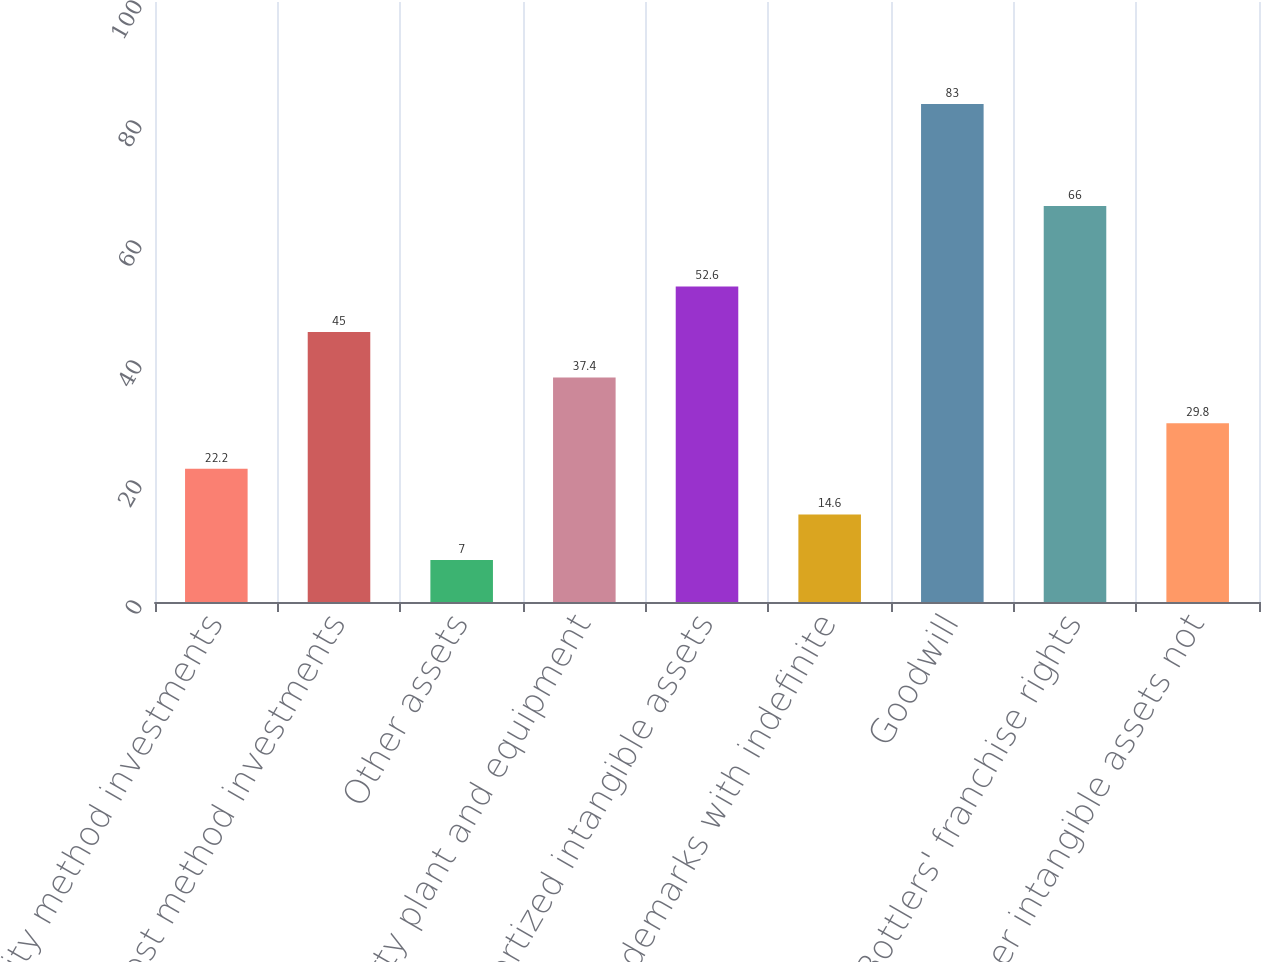Convert chart. <chart><loc_0><loc_0><loc_500><loc_500><bar_chart><fcel>Equity method investments<fcel>Cost method investments<fcel>Other assets<fcel>Property plant and equipment<fcel>Amortized intangible assets<fcel>Trademarks with indefinite<fcel>Goodwill<fcel>Bottlers' franchise rights<fcel>Other intangible assets not<nl><fcel>22.2<fcel>45<fcel>7<fcel>37.4<fcel>52.6<fcel>14.6<fcel>83<fcel>66<fcel>29.8<nl></chart> 